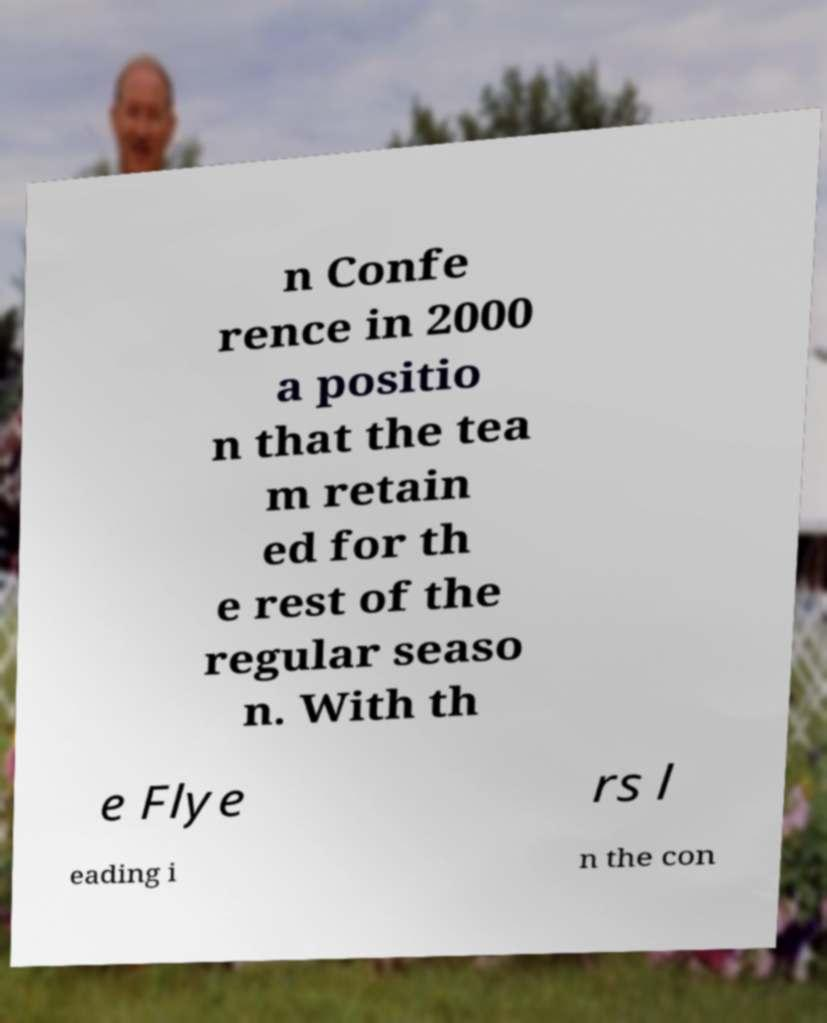Please identify and transcribe the text found in this image. n Confe rence in 2000 a positio n that the tea m retain ed for th e rest of the regular seaso n. With th e Flye rs l eading i n the con 